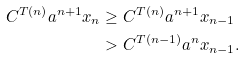Convert formula to latex. <formula><loc_0><loc_0><loc_500><loc_500>C ^ { T ( n ) } a ^ { n + 1 } x _ { n } & \geq C ^ { T ( n ) } a ^ { n + 1 } x _ { n - 1 } \\ & > C ^ { T ( n - 1 ) } a ^ { n } x _ { n - 1 } .</formula> 